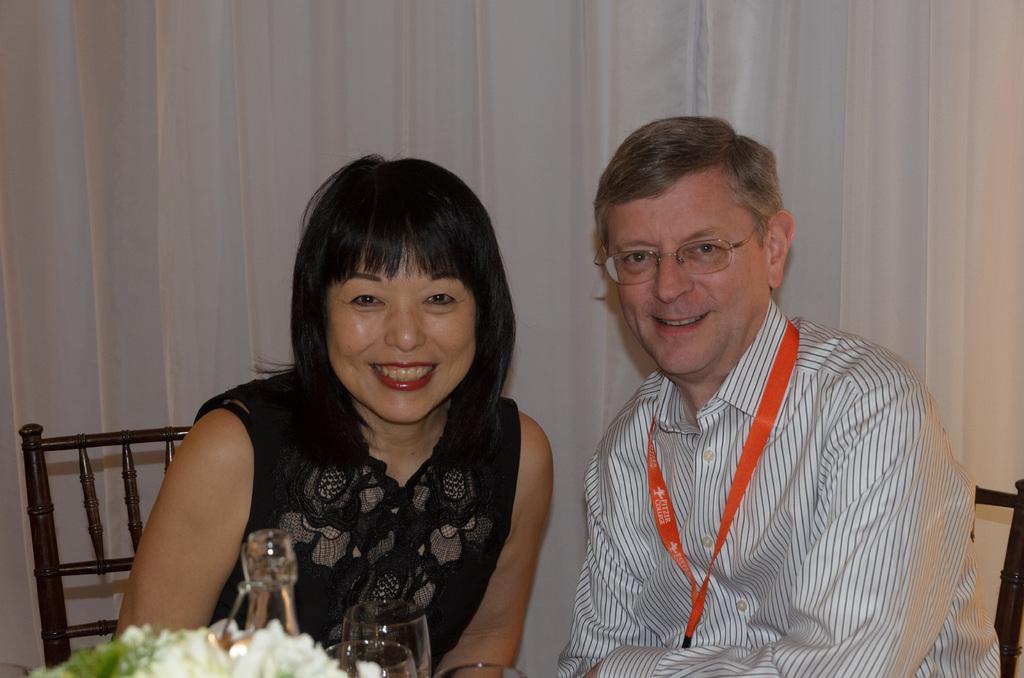Describe this image in one or two sentences. In this image we can see a man and a woman. They are smiling. Here we can see glasses and flowers. In the background we can see a curtain. 